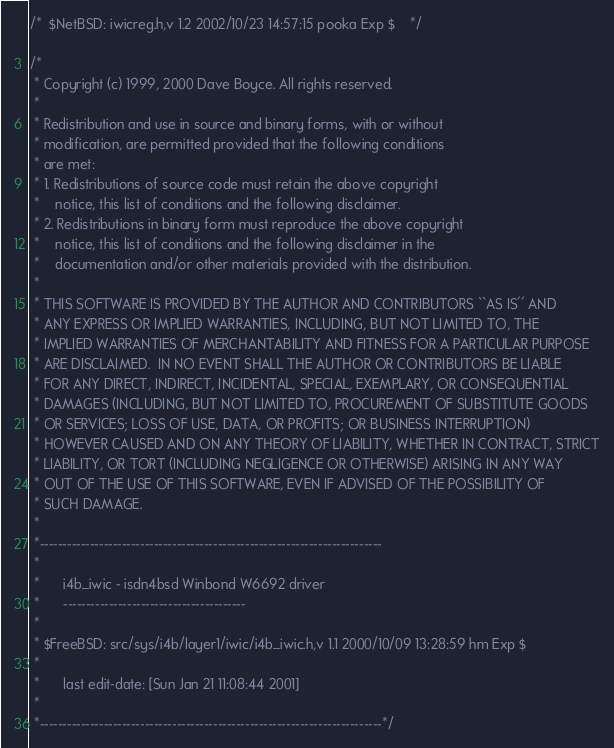<code> <loc_0><loc_0><loc_500><loc_500><_C_>/*	$NetBSD: iwicreg.h,v 1.2 2002/10/23 14:57:15 pooka Exp $	*/

/*
 * Copyright (c) 1999, 2000 Dave Boyce. All rights reserved.
 *
 * Redistribution and use in source and binary forms, with or without
 * modification, are permitted provided that the following conditions
 * are met:
 * 1. Redistributions of source code must retain the above copyright
 *    notice, this list of conditions and the following disclaimer.
 * 2. Redistributions in binary form must reproduce the above copyright
 *    notice, this list of conditions and the following disclaimer in the
 *    documentation and/or other materials provided with the distribution.
 *
 * THIS SOFTWARE IS PROVIDED BY THE AUTHOR AND CONTRIBUTORS ``AS IS'' AND
 * ANY EXPRESS OR IMPLIED WARRANTIES, INCLUDING, BUT NOT LIMITED TO, THE
 * IMPLIED WARRANTIES OF MERCHANTABILITY AND FITNESS FOR A PARTICULAR PURPOSE
 * ARE DISCLAIMED.  IN NO EVENT SHALL THE AUTHOR OR CONTRIBUTORS BE LIABLE
 * FOR ANY DIRECT, INDIRECT, INCIDENTAL, SPECIAL, EXEMPLARY, OR CONSEQUENTIAL
 * DAMAGES (INCLUDING, BUT NOT LIMITED TO, PROCUREMENT OF SUBSTITUTE GOODS
 * OR SERVICES; LOSS OF USE, DATA, OR PROFITS; OR BUSINESS INTERRUPTION)
 * HOWEVER CAUSED AND ON ANY THEORY OF LIABILITY, WHETHER IN CONTRACT, STRICT
 * LIABILITY, OR TORT (INCLUDING NEGLIGENCE OR OTHERWISE) ARISING IN ANY WAY
 * OUT OF THE USE OF THIS SOFTWARE, EVEN IF ADVISED OF THE POSSIBILITY OF
 * SUCH DAMAGE.
 *
 *---------------------------------------------------------------------------
 *
 *      i4b_iwic - isdn4bsd Winbond W6692 driver
 *      ----------------------------------------
 *
 * $FreeBSD: src/sys/i4b/layer1/iwic/i4b_iwic.h,v 1.1 2000/10/09 13:28:59 hm Exp $
 *
 *      last edit-date: [Sun Jan 21 11:08:44 2001]
 *
 *---------------------------------------------------------------------------*/
</code> 